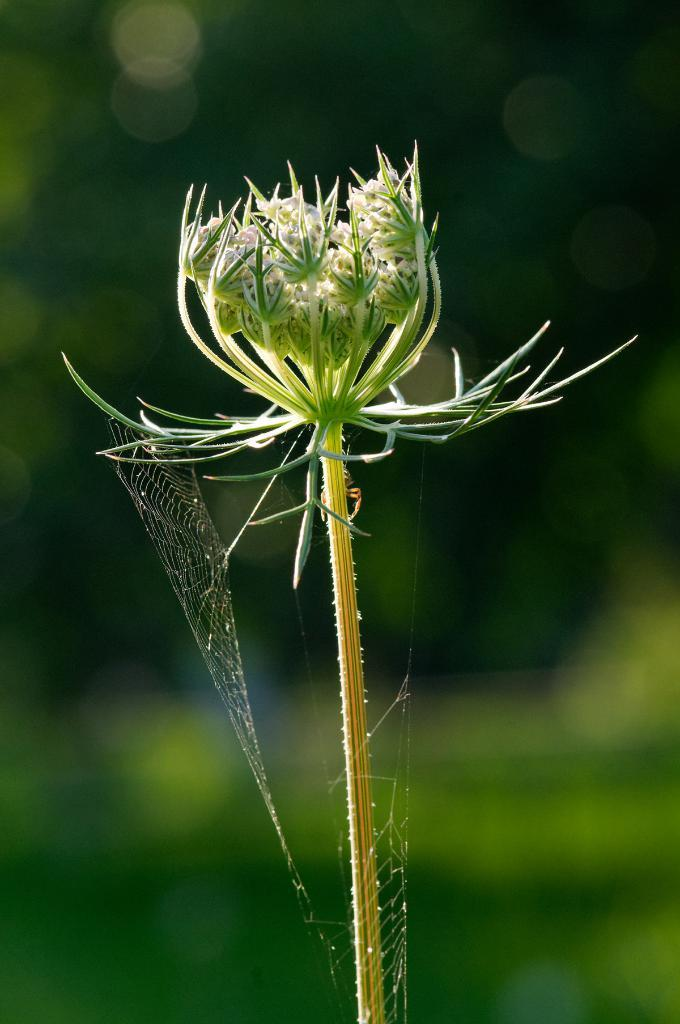What is the main subject of the image? The main subject of the image is a flower bud. Can you describe the flower bud in more detail? The flower bud has a stem. What else can be seen in the image besides the flower bud? There is a spider web in the image. How is the spider web related to the flower bud or its stem? The spider web is associated with the flower bud or its stem. What type of crown is the flower bud wearing in the image? There is no crown present in the image; the flower bud is not wearing any type of crown. 